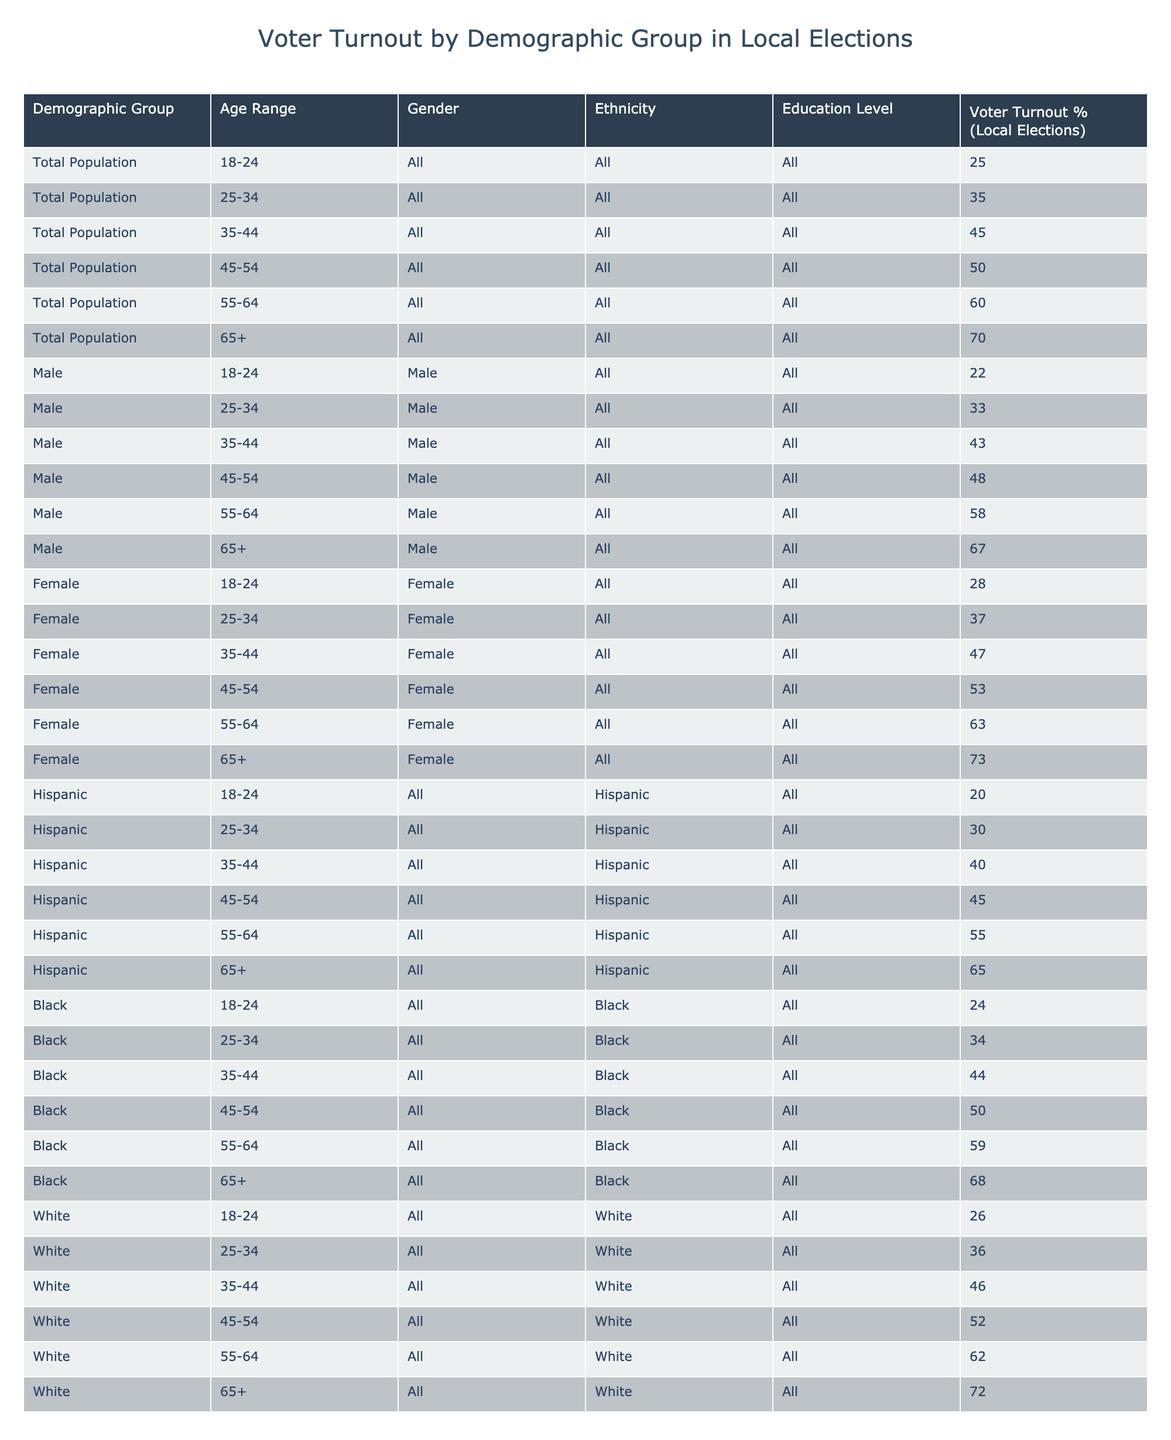What is the voter turnout percentage for females aged 65 and older? Looking at the table, the row corresponding to "Female, 65+" shows a voter turnout percentage of 73.
Answer: 73 What is the voter turnout percentage for males aged 35-44? The table lists the row for "Male, 35-44," which indicates a voter turnout percentage of 43.
Answer: 43 Which demographic group has the highest voter turnout percentage? Reviewing the table, the group "Female, 65+" has the highest voter turnout at 73%.
Answer: 73% What is the average voter turnout percentage for the age group 25-34 across all demographic groups? We look at the rows for all demographic groups aged 25-34: Male (33), Female (37), Hispanic (30), Black (34), and White (36). The average is (33 + 37 + 30 + 34 + 36) / 5 = 34.
Answer: 34 Is the voter turnout for Black individuals aged 25-34 higher than that for Hispanic individuals in the same age range? The table shows that Black individuals aged 25-34 have a voter turnout of 34%, and Hispanic individuals in the same age range have 30%. Since 34% is greater than 30%, the answer is Yes.
Answer: Yes What is the difference in voter turnout percentage between males and females aged 55-64? For males aged 55-64, the turnout is 58%, while for females of the same age, it is 63%. The difference is 63 - 58 = 5%.
Answer: 5% How many demographic groups have a voter turnout percentage of 50% or higher? According to the table, we identify the groups with 50% or higher turnout: 45-54 (50) and 55-64 (60) and 65+ (70) for all, and females and males also in respective categories. Counting these rows gives us a total of 8 groups.
Answer: 8 What is the voter turnout percentage for the total population aged 45-54? The table indicates that the voter turnout percentage for the total population in the 45-54 age range is 50%.
Answer: 50 Which age range has the lowest voter turnout percentage among males? By reviewing the rows for male demographic groups, we see "Male, 18-24" has the lowest turnout at 22%.
Answer: 22 